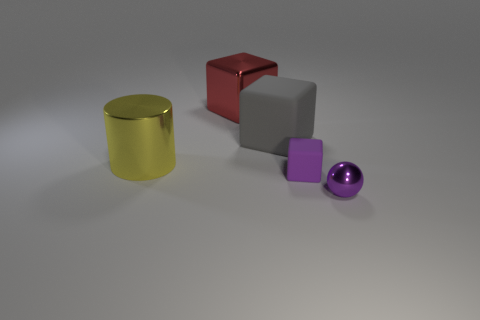What materials are the objects made of in the image? The objects appear to be rendered with different material finishes. The cylindrical object has a reflective metallic finish, the cube has a matte finish, the small cube looks like plastic, and the sphere has a glossy surface, possibly representing a polished metal or a glass material. 